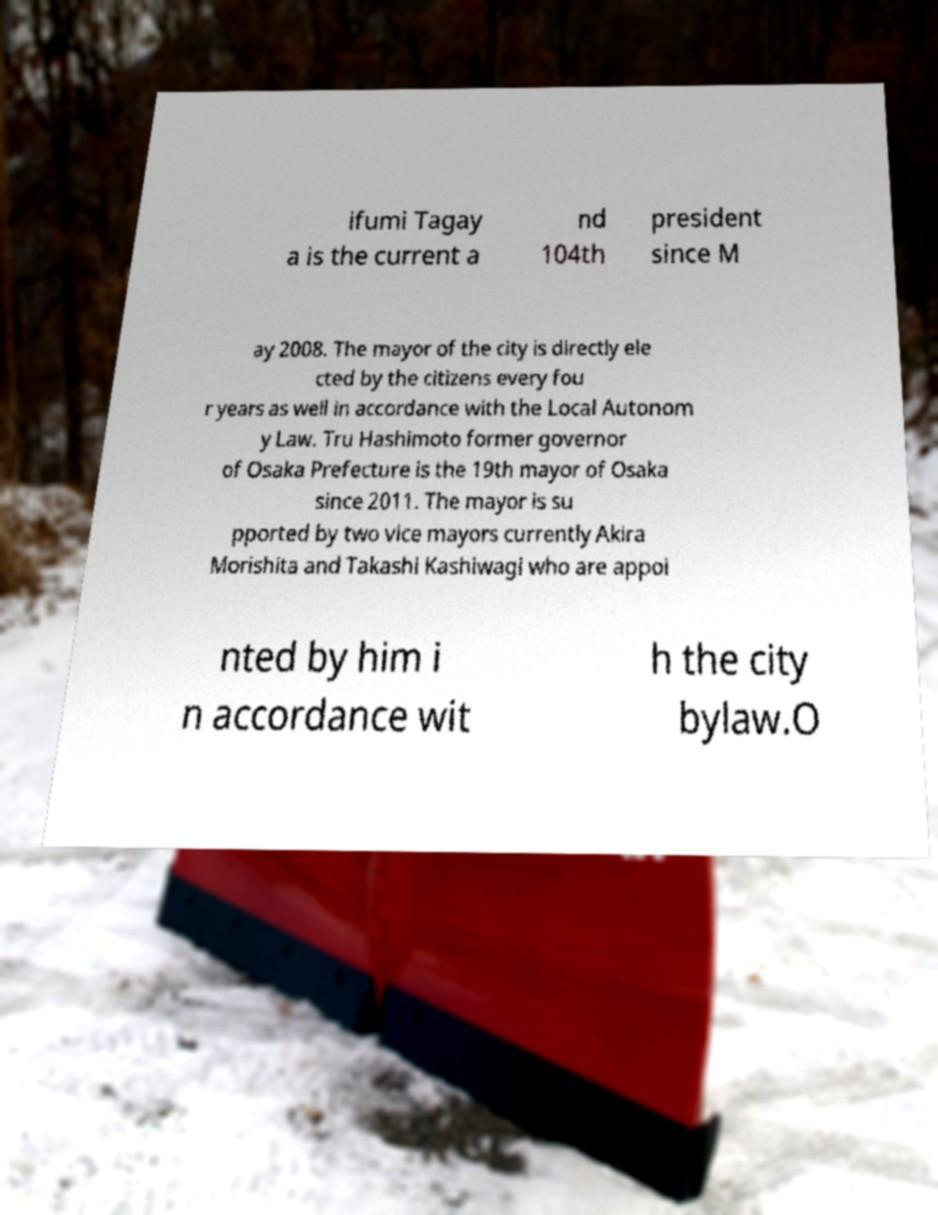Could you assist in decoding the text presented in this image and type it out clearly? ifumi Tagay a is the current a nd 104th president since M ay 2008. The mayor of the city is directly ele cted by the citizens every fou r years as well in accordance with the Local Autonom y Law. Tru Hashimoto former governor of Osaka Prefecture is the 19th mayor of Osaka since 2011. The mayor is su pported by two vice mayors currently Akira Morishita and Takashi Kashiwagi who are appoi nted by him i n accordance wit h the city bylaw.O 